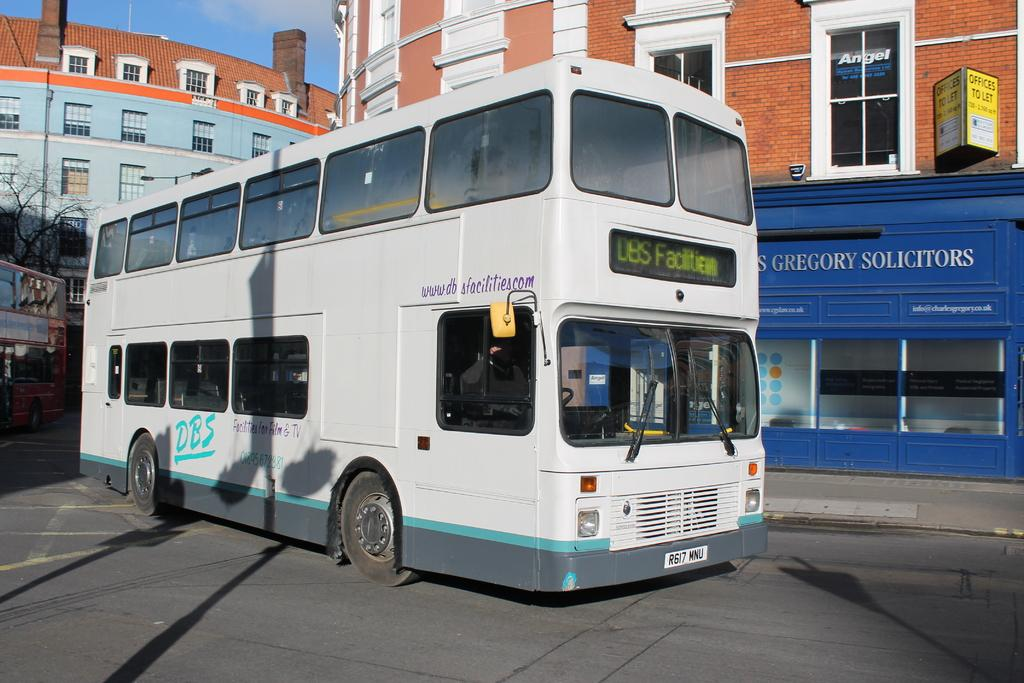What is the main subject of the image? The main subject of the image is a bus. Where is the bus located in the image? The bus is on the road in the image. What can be seen in the background of the image? There are buildings behind the bus in the image. What type of ground is visible beneath the bus in the image? The image does not provide enough detail to determine the type of ground beneath the bus. Is there any evidence of trade happening in the image? There is no indication of trade in the image; it simply shows a bus on the road with buildings in the background. 